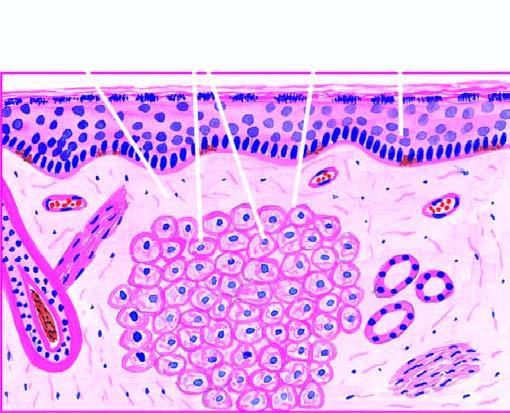what is collection of proliferating foam macrophages in the dermis with?
Answer the question using a single word or phrase. A clear subepidermal zone 